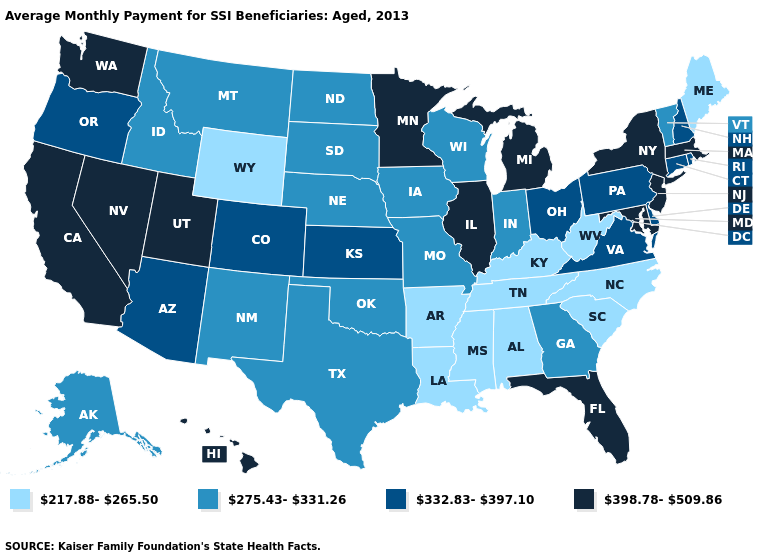Does Illinois have a higher value than Oklahoma?
Write a very short answer. Yes. What is the highest value in the USA?
Concise answer only. 398.78-509.86. What is the value of Arkansas?
Quick response, please. 217.88-265.50. Among the states that border Oklahoma , does Colorado have the highest value?
Give a very brief answer. Yes. Among the states that border New Hampshire , which have the highest value?
Answer briefly. Massachusetts. Does Oregon have the highest value in the West?
Keep it brief. No. What is the lowest value in states that border South Carolina?
Write a very short answer. 217.88-265.50. Among the states that border Pennsylvania , which have the highest value?
Short answer required. Maryland, New Jersey, New York. What is the value of Alaska?
Short answer required. 275.43-331.26. Which states have the lowest value in the USA?
Give a very brief answer. Alabama, Arkansas, Kentucky, Louisiana, Maine, Mississippi, North Carolina, South Carolina, Tennessee, West Virginia, Wyoming. What is the lowest value in the USA?
Be succinct. 217.88-265.50. Does the first symbol in the legend represent the smallest category?
Answer briefly. Yes. What is the value of Maryland?
Be succinct. 398.78-509.86. Does Wyoming have the lowest value in the USA?
Be succinct. Yes. 